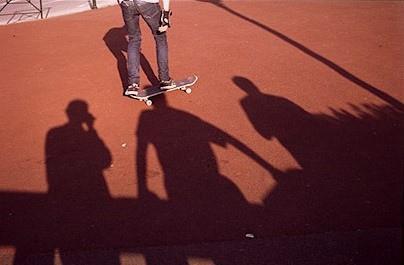How many shadows do you see?
Give a very brief answer. 4. How many bodies can you see in this image?
Give a very brief answer. 1. How many people can be seen?
Give a very brief answer. 2. How many blue drinking cups are in the picture?
Give a very brief answer. 0. 